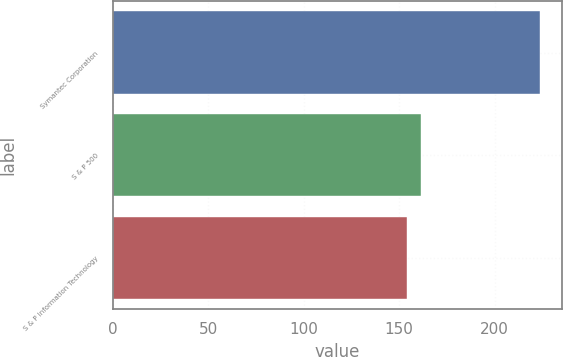<chart> <loc_0><loc_0><loc_500><loc_500><bar_chart><fcel>Symantec Corporation<fcel>S & P 500<fcel>S & P Information Technology<nl><fcel>223.91<fcel>161.25<fcel>154.29<nl></chart> 